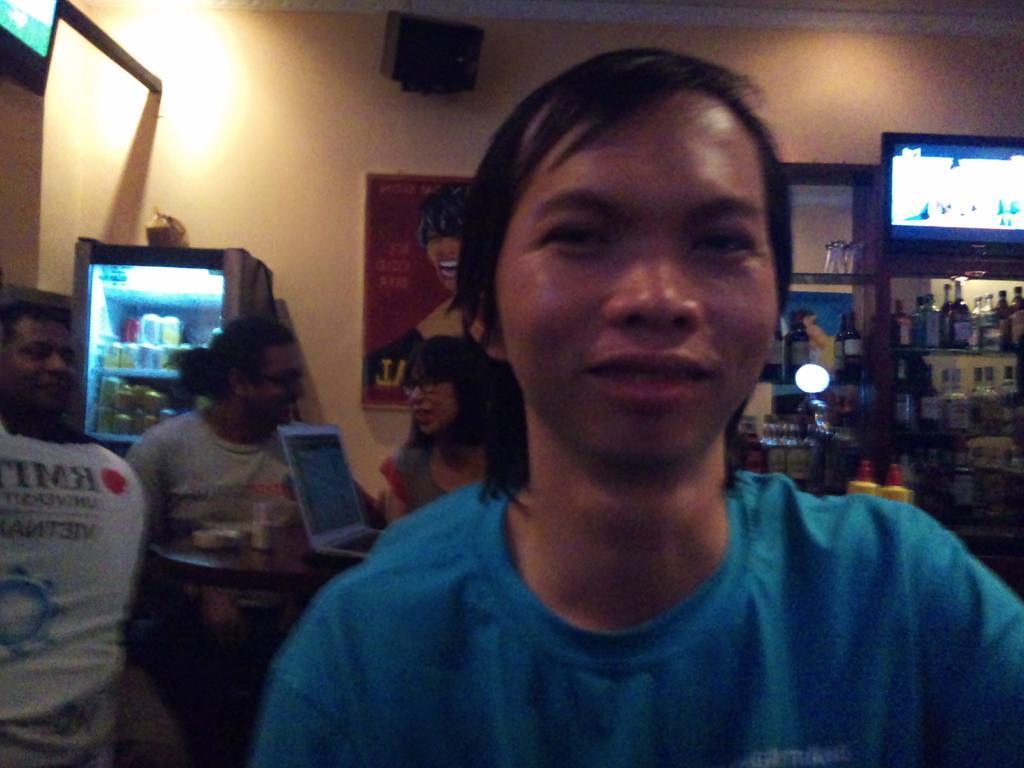Please provide a concise description of this image. In the image there is a person in blue t-shirt in the front and behind him there are few persons visible with laptops in front of them on the table, in the background there are fridges with wine bottles on either side with a photograph on the middle of the wall. 